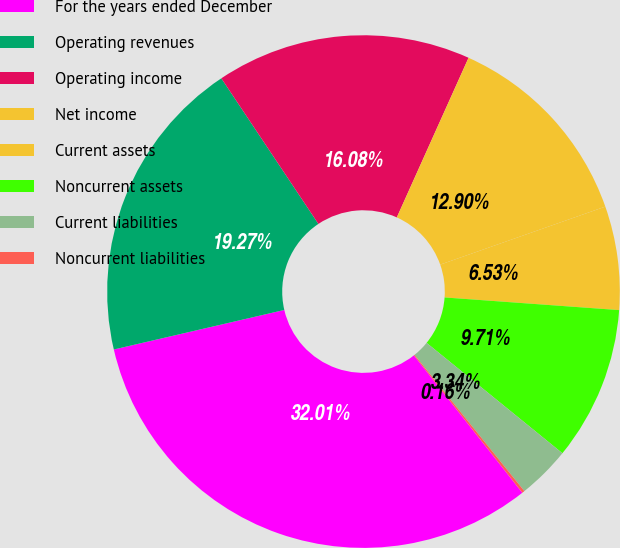<chart> <loc_0><loc_0><loc_500><loc_500><pie_chart><fcel>For the years ended December<fcel>Operating revenues<fcel>Operating income<fcel>Net income<fcel>Current assets<fcel>Noncurrent assets<fcel>Current liabilities<fcel>Noncurrent liabilities<nl><fcel>32.01%<fcel>19.27%<fcel>16.08%<fcel>12.9%<fcel>6.53%<fcel>9.71%<fcel>3.34%<fcel>0.16%<nl></chart> 